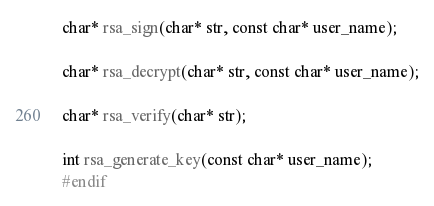Convert code to text. <code><loc_0><loc_0><loc_500><loc_500><_C_>
char* rsa_sign(char* str, const char* user_name);

char* rsa_decrypt(char* str, const char* user_name);

char* rsa_verify(char* str);

int rsa_generate_key(const char* user_name);
#endif
</code> 